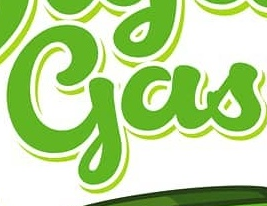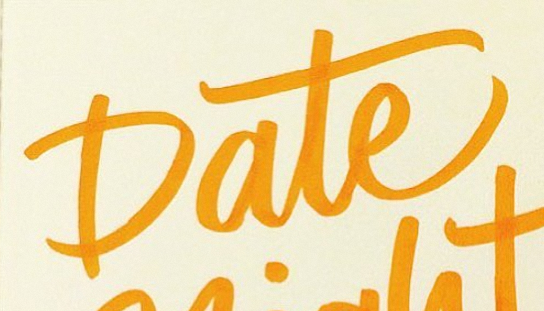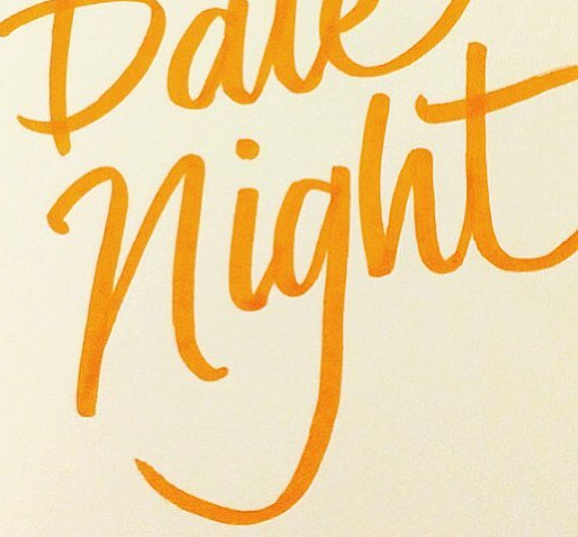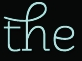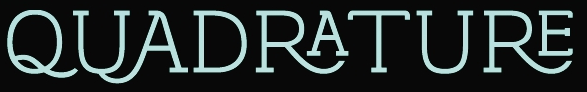What words can you see in these images in sequence, separated by a semicolon? gas; Date; night; the; QUADRATURE 